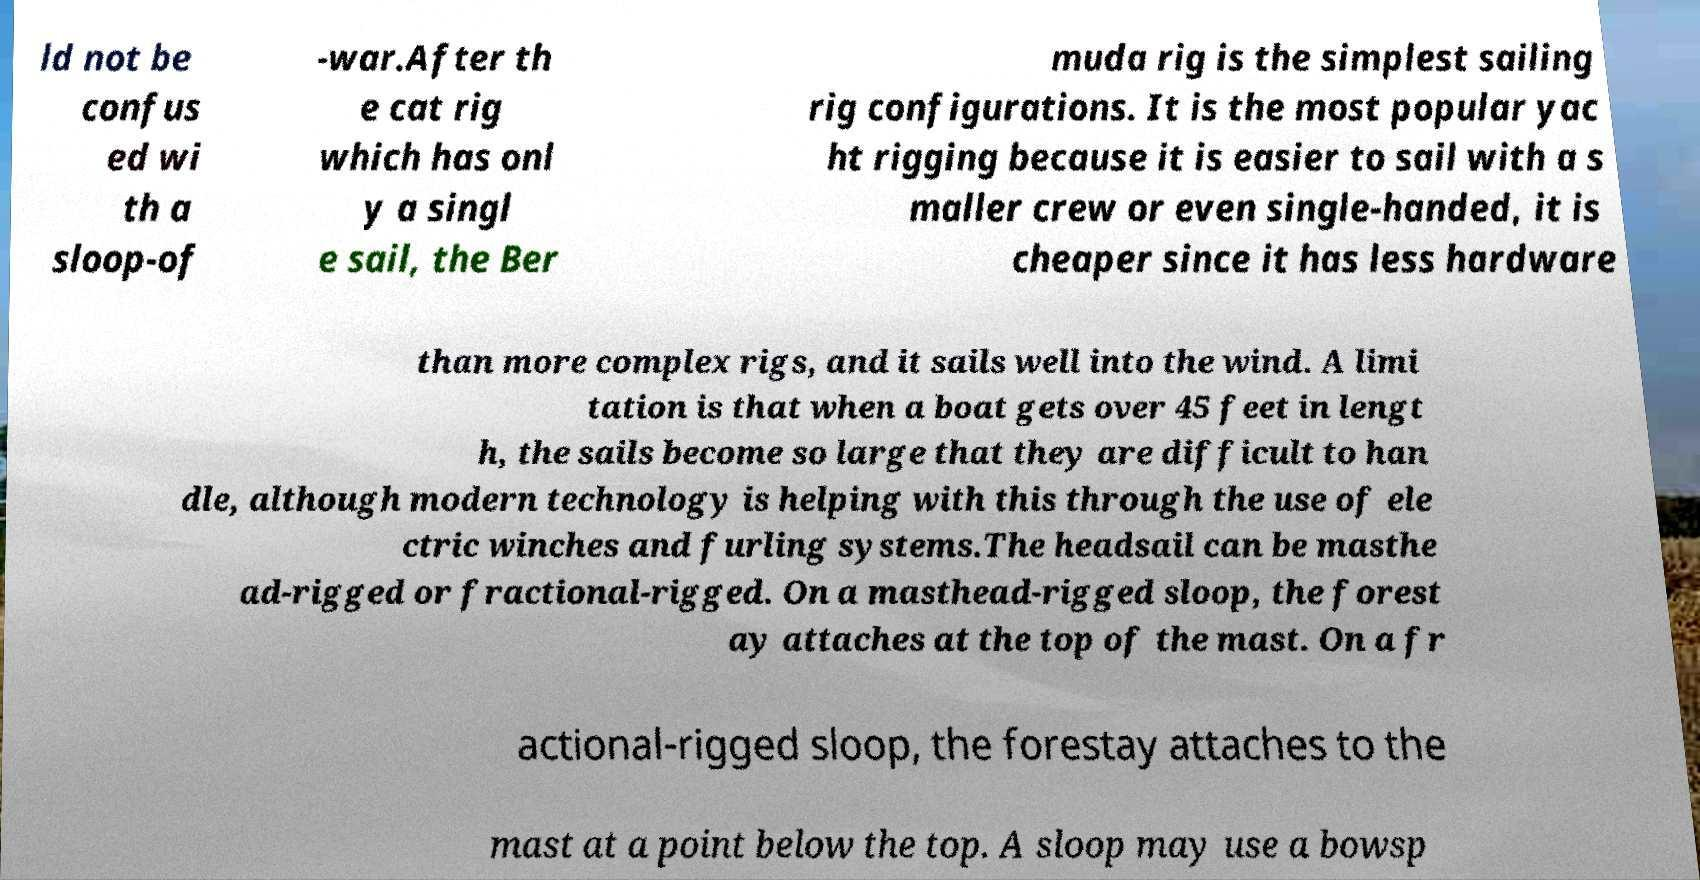Please identify and transcribe the text found in this image. ld not be confus ed wi th a sloop-of -war.After th e cat rig which has onl y a singl e sail, the Ber muda rig is the simplest sailing rig configurations. It is the most popular yac ht rigging because it is easier to sail with a s maller crew or even single-handed, it is cheaper since it has less hardware than more complex rigs, and it sails well into the wind. A limi tation is that when a boat gets over 45 feet in lengt h, the sails become so large that they are difficult to han dle, although modern technology is helping with this through the use of ele ctric winches and furling systems.The headsail can be masthe ad-rigged or fractional-rigged. On a masthead-rigged sloop, the forest ay attaches at the top of the mast. On a fr actional-rigged sloop, the forestay attaches to the mast at a point below the top. A sloop may use a bowsp 